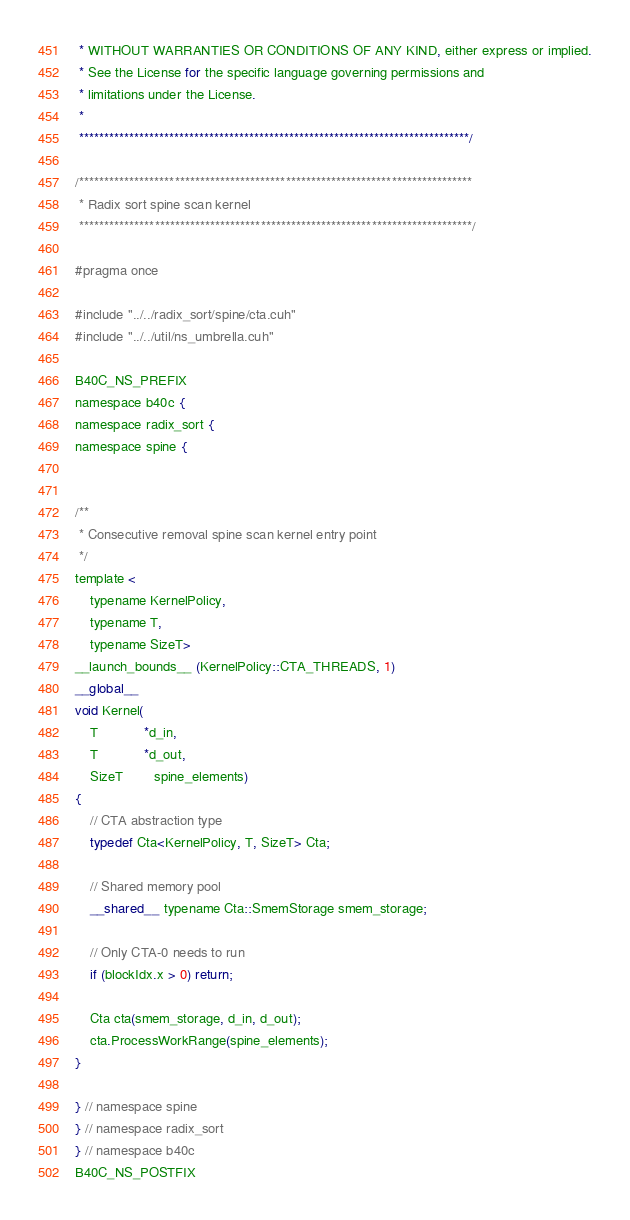<code> <loc_0><loc_0><loc_500><loc_500><_Cuda_> * WITHOUT WARRANTIES OR CONDITIONS OF ANY KIND, either express or implied.
 * See the License for the specific language governing permissions and
 * limitations under the License. 
 * 
 ******************************************************************************/

/******************************************************************************
 * Radix sort spine scan kernel
 ******************************************************************************/

#pragma once

#include "../../radix_sort/spine/cta.cuh"
#include "../../util/ns_umbrella.cuh"

B40C_NS_PREFIX
namespace b40c {
namespace radix_sort {
namespace spine {


/**
 * Consecutive removal spine scan kernel entry point
 */
template <
	typename KernelPolicy,
	typename T,
	typename SizeT>
__launch_bounds__ (KernelPolicy::CTA_THREADS, 1)
__global__ 
void Kernel(
	T			*d_in,
	T			*d_out,
	SizeT 		spine_elements)
{
	// CTA abstraction type
	typedef Cta<KernelPolicy, T, SizeT> Cta;

	// Shared memory pool
	__shared__ typename Cta::SmemStorage smem_storage;

	// Only CTA-0 needs to run
	if (blockIdx.x > 0) return;

	Cta cta(smem_storage, d_in, d_out);
	cta.ProcessWorkRange(spine_elements);
}

} // namespace spine
} // namespace radix_sort
} // namespace b40c
B40C_NS_POSTFIX
</code> 